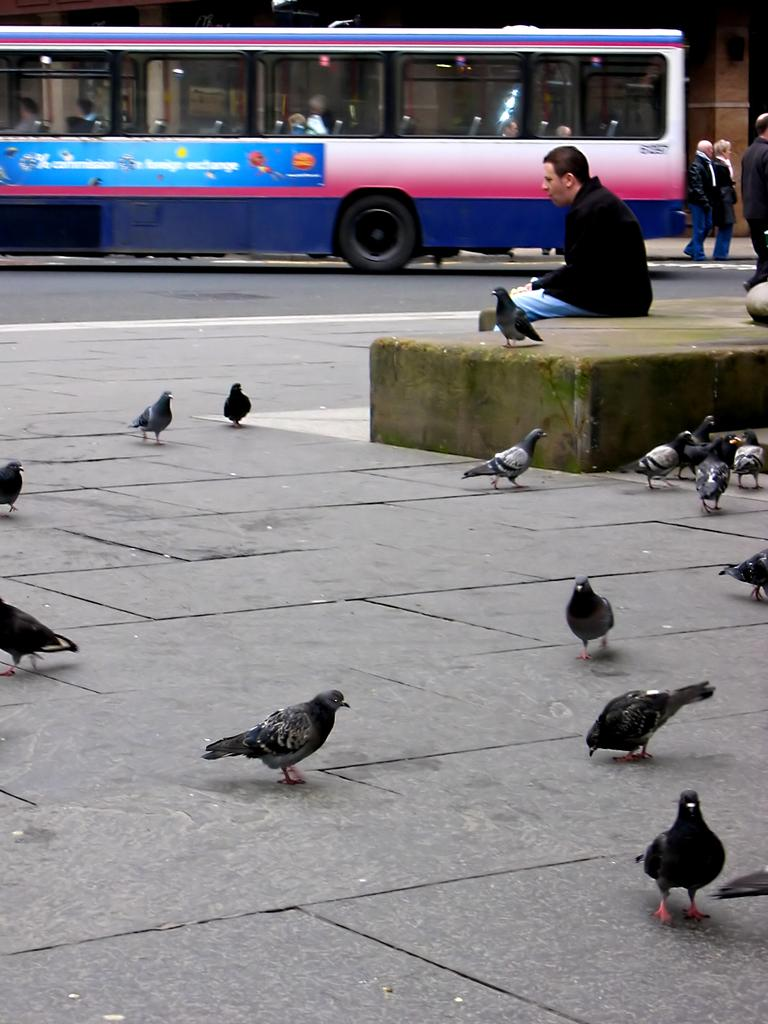What can be seen in the foreground of the picture? There are pigeons on the pavement in the foreground of the picture. What is located in the center of the picture? There are people in the center of the picture. What can be seen in the background of the picture? There are people, a bus, a building, and a road in the background of the picture. Can you describe the furniture around the lake in the image? There is no lake or furniture present in the image. What type of room is visible in the background of the image? There is no room visible in the image; it features a road, a bus, and a building in the background. 